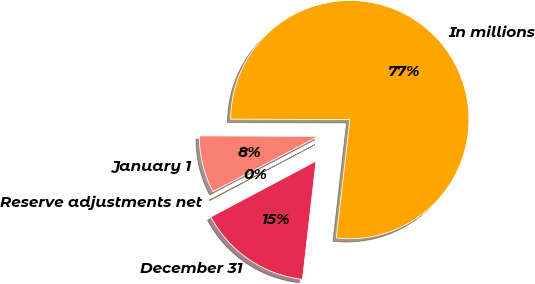<chart> <loc_0><loc_0><loc_500><loc_500><pie_chart><fcel>In millions<fcel>January 1<fcel>Reserve adjustments net<fcel>December 31<nl><fcel>76.76%<fcel>7.75%<fcel>0.08%<fcel>15.41%<nl></chart> 